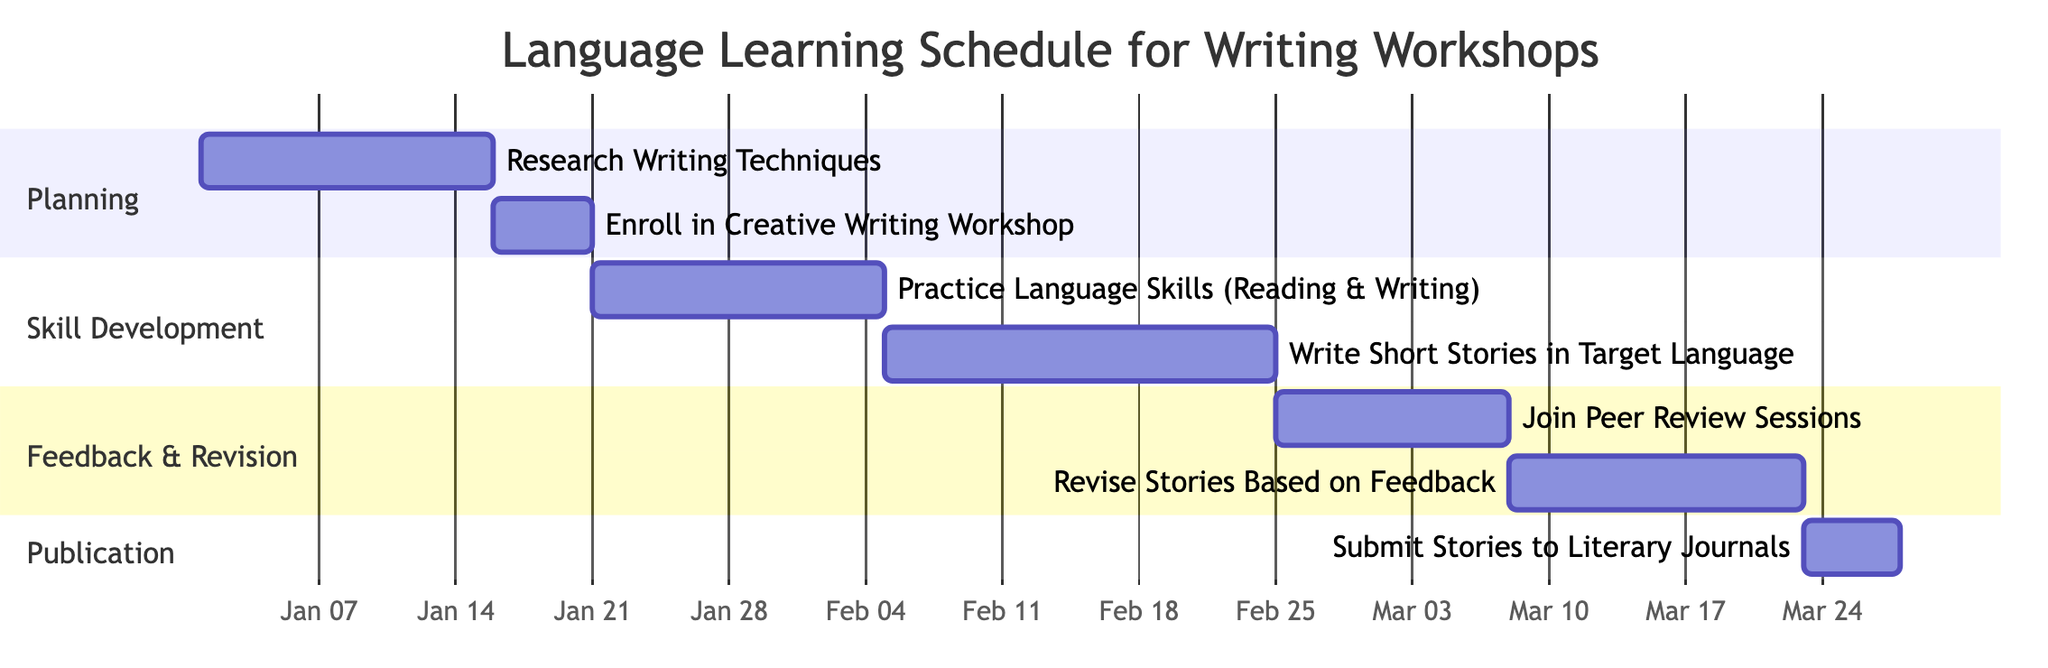What is the total duration of the 'Skill Development' section? The 'Skill Development' section includes two tasks: 'Practice Language Skills (Reading & Writing)' lasting 15 days and 'Write Short Stories in Target Language' lasting 20 days. Therefore, the total duration is 15 days + 20 days = 35 days.
Answer: 35 days When does the 'Join Peer Review Sessions' task start? The 'Join Peer Review Sessions' task starts immediately after the completion of the 'Write Short Stories in Target Language' task, which ends on 2024-02-26. Therefore, it starts on 2024-02-27.
Answer: 2024-02-27 How many tasks are there in the entire schedule? The diagram outlines a total of 7 tasks: 'Research Writing Techniques', 'Enroll in Creative Writing Workshop', 'Practice Language Skills (Reading & Writing)', 'Write Short Stories in Target Language', 'Join Peer Review Sessions', 'Revise Stories Based on Feedback', and 'Submit Stories to Literary Journals'. Counting these gives a total of 7 tasks.
Answer: 7 What task follows 'Revise Stories Based on Feedback'? The 'Submit Stories to Literary Journals' task follows 'Revise Stories Based on Feedback'. This is determined by the sequential flow of tasks in the diagram where 'Revise Stories Based on Feedback' directly leads into 'Submit Stories to Literary Journals'.
Answer: Submit Stories to Literary Journals What is the start date of the 'Enroll in Creative Writing Workshop'? The 'Enroll in Creative Writing Workshop' task starts on 2024-01-16, as it begins immediately after the 'Research Writing Techniques' task, which ends on 2024-01-15.
Answer: 2024-01-16 What is the total duration of the 'Publication' section? The 'Publication' section contains one task: 'Submit Stories to Literary Journals', which has a duration of 5 days. Since there are no other tasks or overlaps, the total duration is simply the duration of this single task.
Answer: 5 days Which task has the longest duration in this schedule? The task with the longest duration is 'Write Short Stories in Target Language', which lasts for 20 days, the longest individual task duration when compared to others listed in the diagram.
Answer: Write Short Stories in Target Language 